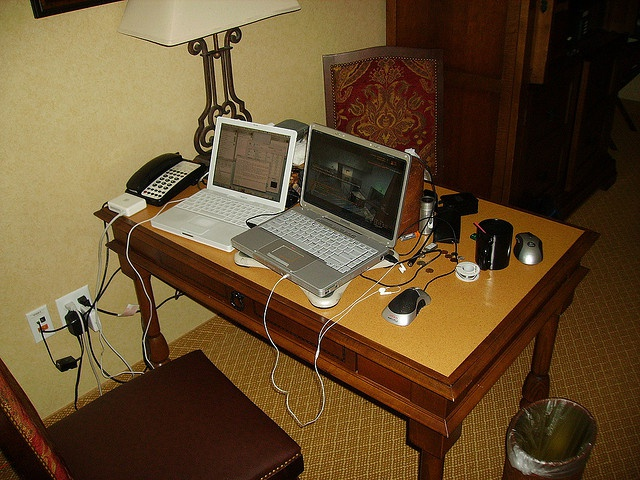Describe the objects in this image and their specific colors. I can see chair in olive, black, and maroon tones, laptop in olive, black, gray, and darkgray tones, chair in olive, maroon, and black tones, laptop in olive, darkgray, gray, and lightgray tones, and mouse in olive, black, white, gray, and darkgray tones in this image. 